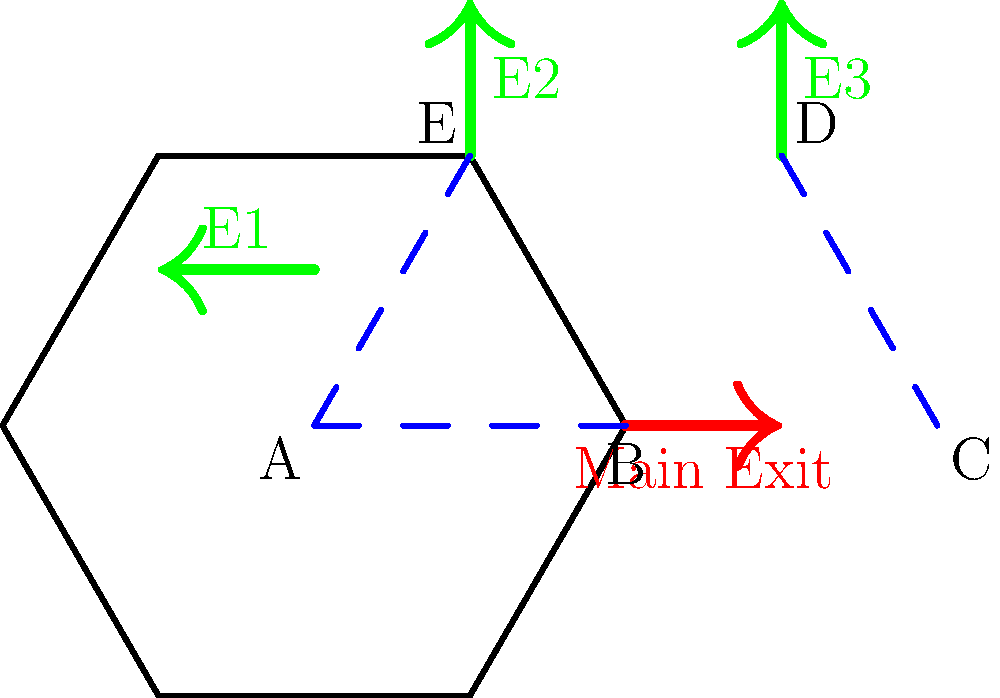In the palace floor plan shown, emergency exits E1, E2, and E3 have been added to supplement the main exit. Which two evacuation routes are congruent, ensuring equal escape times for royal family members in different areas of the palace? To determine which evacuation routes are congruent, we need to analyze the geometric properties of the triangles formed by these routes:

1. The floor plan is a regular hexagon, which can be divided into six equilateral triangles.

2. We have three evacuation routes to compare:
   a) Route AB to the main exit
   b) Route AE to emergency exit E1
   c) Route CD to emergency exit E3

3. Let's examine each route:
   a) Route AB is a side of the hexagon
   b) Route AE is a radius of the hexagon (from center to vertex)
   c) Route CD is also a radius of the hexagon

4. In a regular hexagon:
   - All sides are equal
   - All radii are equal
   - The radius is equal to the side length

5. Therefore, we can conclude that:
   - Route AB (side) = Route AE (radius) = Route CD (radius)

6. Since these routes have equal lengths and are part of equilateral triangles (formed by the hexagon's structure), they are congruent.

7. The congruent routes are AE (to E1) and CD (to E3).

This congruence ensures that royal family members in areas A and C have equal escape times to their respective emergency exits.
Answer: AE and CD 